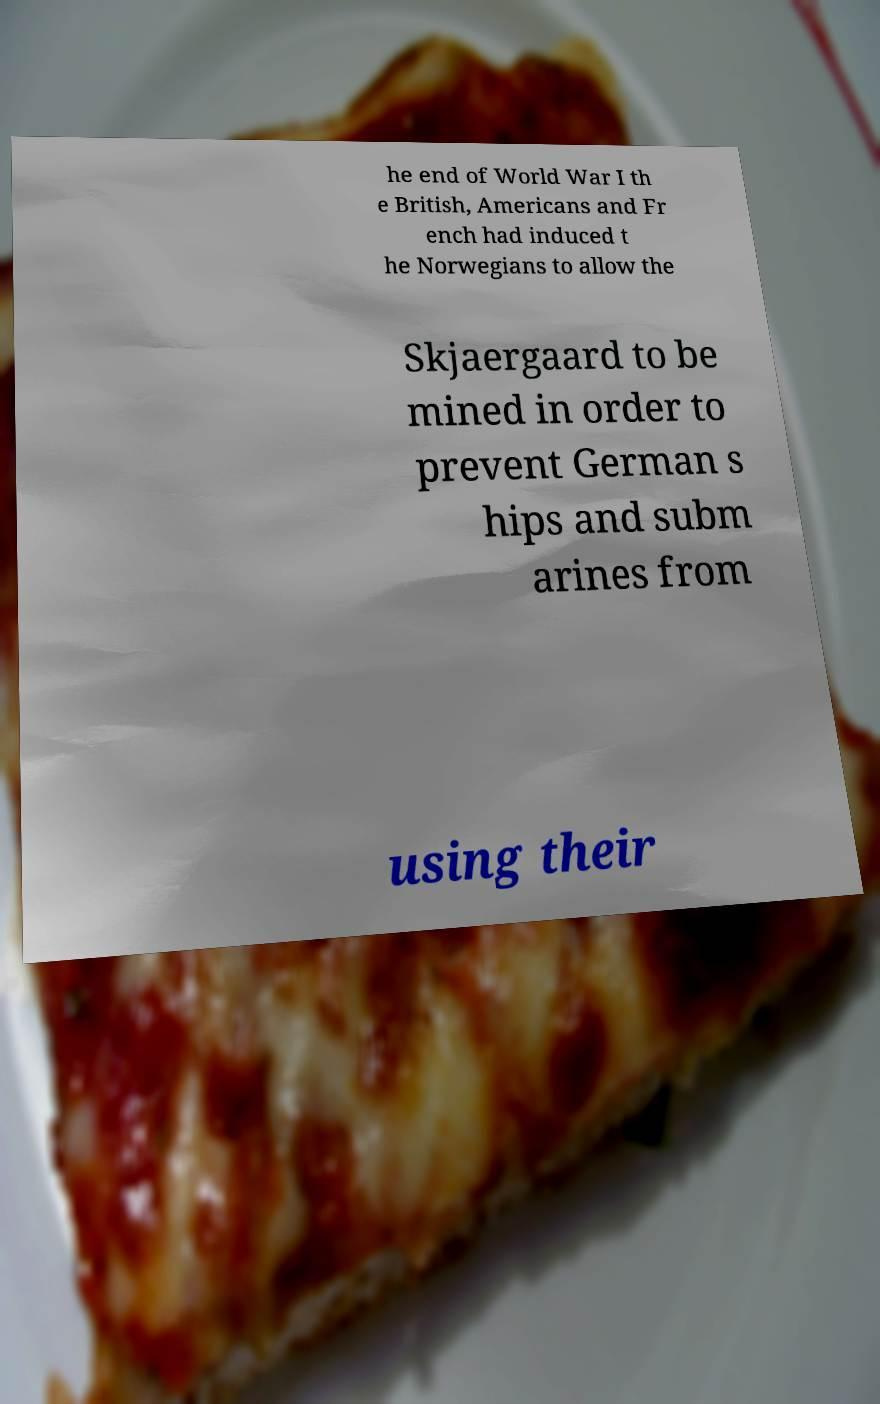For documentation purposes, I need the text within this image transcribed. Could you provide that? he end of World War I th e British, Americans and Fr ench had induced t he Norwegians to allow the Skjaergaard to be mined in order to prevent German s hips and subm arines from using their 